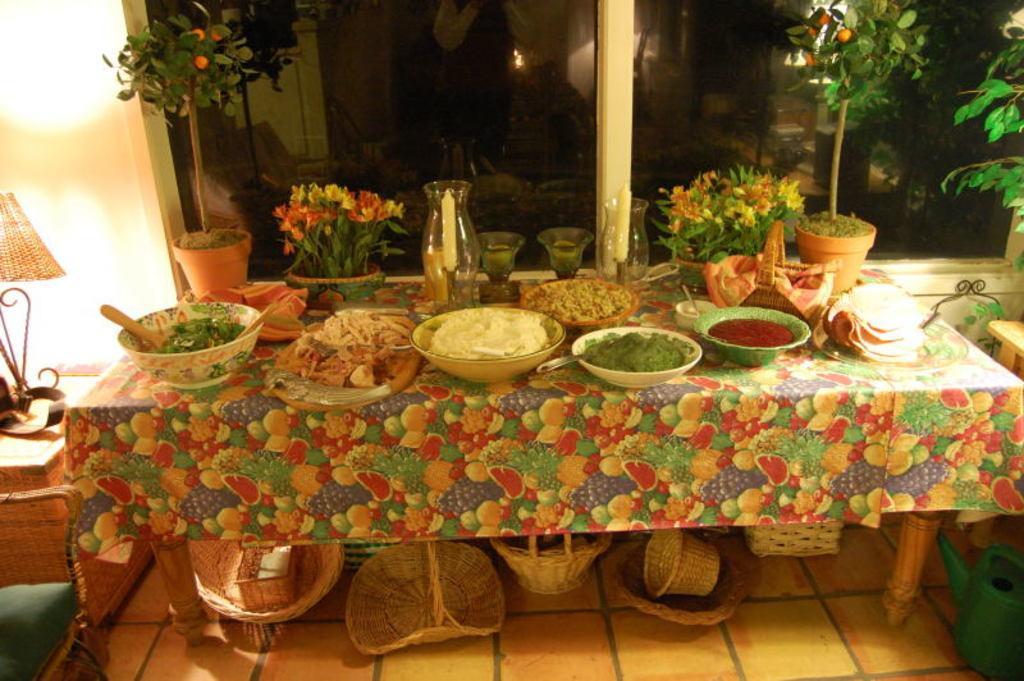Please provide a concise description of this image. In this image I can see a table and on it I can see number of utensils, few plants, few glasses, a candle, a basket, few clothes, different types of food and few other things. I can also see few more baskets under the table. On the right side of the image I can see a green coloured watering can, a plant on the table and on the left side of the image I can see a lamp. 